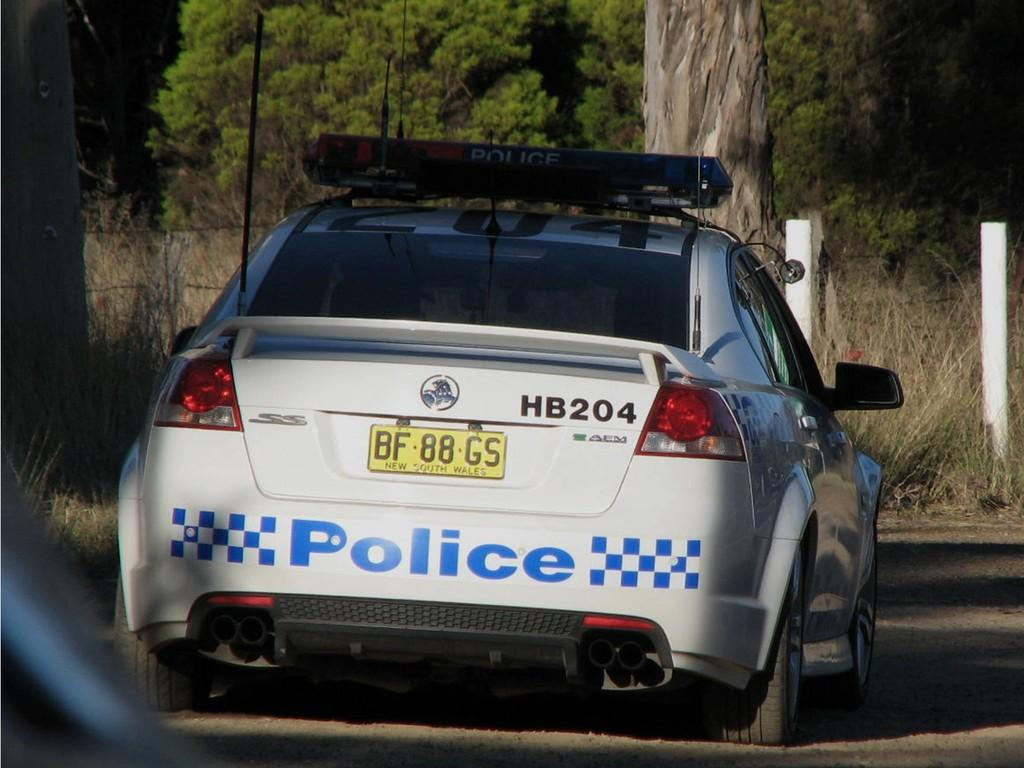<image>
Write a terse but informative summary of the picture. The police car has a license plate number of BF88GS. 